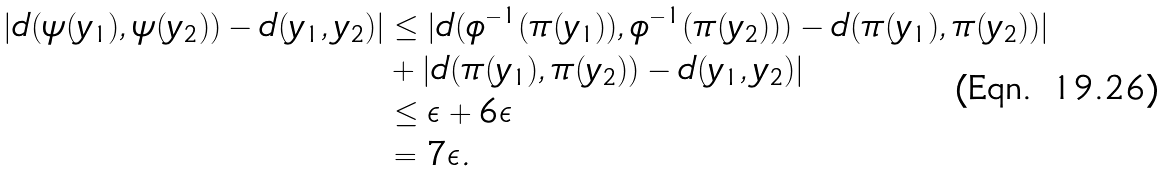Convert formula to latex. <formula><loc_0><loc_0><loc_500><loc_500>| d ( \psi ( y _ { 1 } ) , \psi ( y _ { 2 } ) ) - d ( y _ { 1 } , y _ { 2 } ) | & \leq | d ( \phi ^ { - 1 } ( \pi ( y _ { 1 } ) ) , \phi ^ { - 1 } ( \pi ( y _ { 2 } ) ) ) - d ( \pi ( y _ { 1 } ) , \pi ( y _ { 2 } ) ) | \\ & + | d ( \pi ( y _ { 1 } ) , \pi ( y _ { 2 } ) ) - d ( y _ { 1 } , y _ { 2 } ) | \\ & \leq \epsilon + 6 \epsilon \\ & = 7 \epsilon .</formula> 